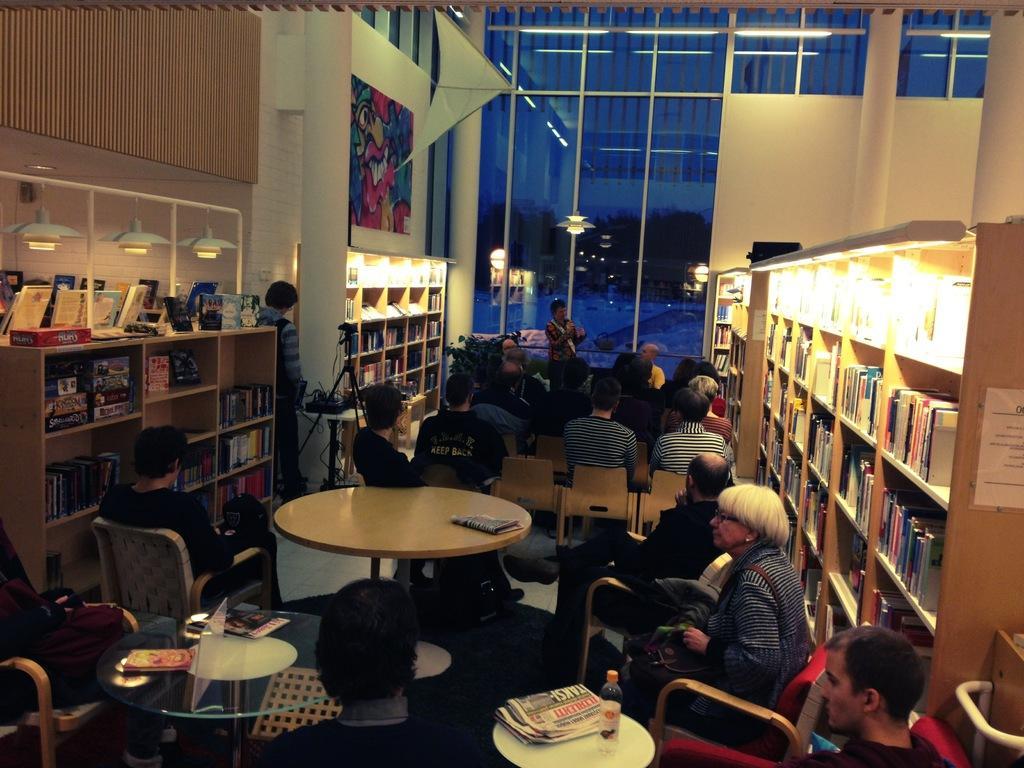Can you describe this image briefly? This picture is clicked inside a room. There are many people sitting on chairs at the table. On the table there are bottles, newspapers, books and magazines. On the both sides of the image there are books placed in the shelves. There are bulbs and lamps in the shelves. On the wall there is picture art. There is also a man standing and in front of him there is a camera on tripod stand. In the background there is a person standing and holding a microphone. Behind the person there is glass and through it sky and trees can be seen.  